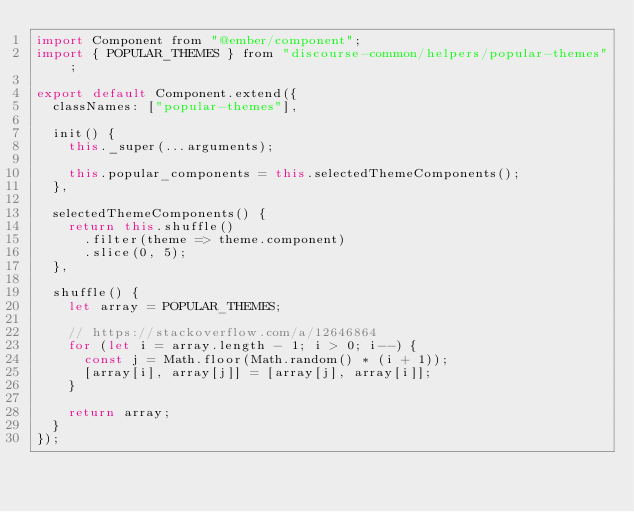Convert code to text. <code><loc_0><loc_0><loc_500><loc_500><_JavaScript_>import Component from "@ember/component";
import { POPULAR_THEMES } from "discourse-common/helpers/popular-themes";

export default Component.extend({
  classNames: ["popular-themes"],

  init() {
    this._super(...arguments);

    this.popular_components = this.selectedThemeComponents();
  },

  selectedThemeComponents() {
    return this.shuffle()
      .filter(theme => theme.component)
      .slice(0, 5);
  },

  shuffle() {
    let array = POPULAR_THEMES;

    // https://stackoverflow.com/a/12646864
    for (let i = array.length - 1; i > 0; i--) {
      const j = Math.floor(Math.random() * (i + 1));
      [array[i], array[j]] = [array[j], array[i]];
    }

    return array;
  }
});
</code> 